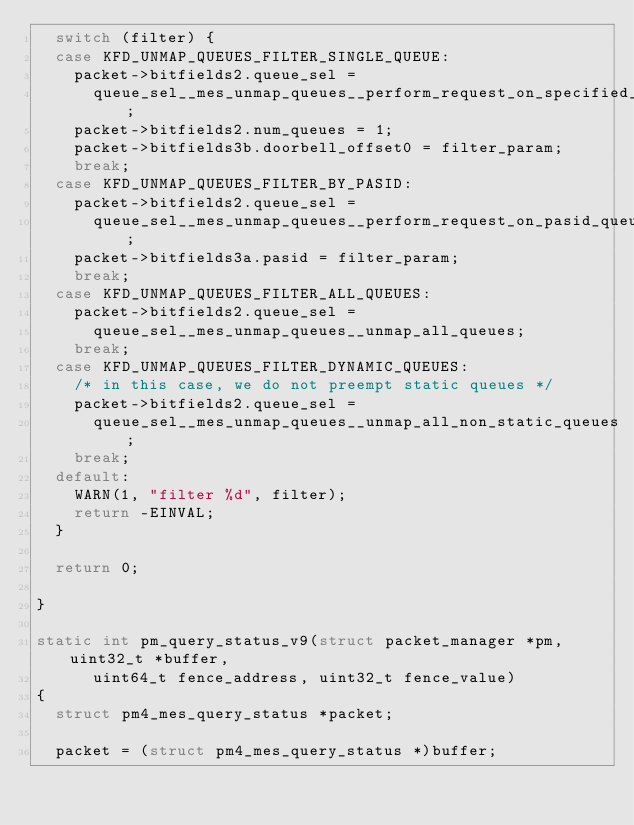<code> <loc_0><loc_0><loc_500><loc_500><_C_>	switch (filter) {
	case KFD_UNMAP_QUEUES_FILTER_SINGLE_QUEUE:
		packet->bitfields2.queue_sel =
			queue_sel__mes_unmap_queues__perform_request_on_specified_queues;
		packet->bitfields2.num_queues = 1;
		packet->bitfields3b.doorbell_offset0 = filter_param;
		break;
	case KFD_UNMAP_QUEUES_FILTER_BY_PASID:
		packet->bitfields2.queue_sel =
			queue_sel__mes_unmap_queues__perform_request_on_pasid_queues;
		packet->bitfields3a.pasid = filter_param;
		break;
	case KFD_UNMAP_QUEUES_FILTER_ALL_QUEUES:
		packet->bitfields2.queue_sel =
			queue_sel__mes_unmap_queues__unmap_all_queues;
		break;
	case KFD_UNMAP_QUEUES_FILTER_DYNAMIC_QUEUES:
		/* in this case, we do not preempt static queues */
		packet->bitfields2.queue_sel =
			queue_sel__mes_unmap_queues__unmap_all_non_static_queues;
		break;
	default:
		WARN(1, "filter %d", filter);
		return -EINVAL;
	}

	return 0;

}

static int pm_query_status_v9(struct packet_manager *pm, uint32_t *buffer,
			uint64_t fence_address,	uint32_t fence_value)
{
	struct pm4_mes_query_status *packet;

	packet = (struct pm4_mes_query_status *)buffer;</code> 